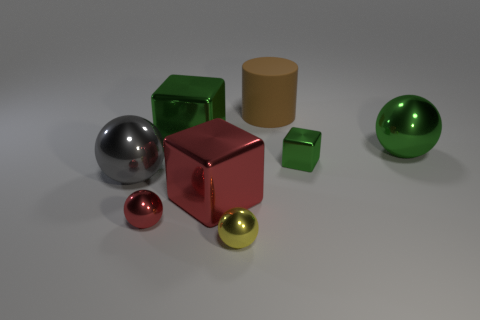Is there any other thing that is the same shape as the large matte thing?
Your answer should be very brief. No. What material is the sphere that is the same color as the small cube?
Provide a succinct answer. Metal. What is the shape of the metal thing that is to the right of the red cube and in front of the big red metal block?
Make the answer very short. Sphere. What is the material of the tiny green object that is right of the cube that is in front of the large gray sphere?
Provide a succinct answer. Metal. Are there more red metallic balls than large red matte balls?
Make the answer very short. Yes. Does the large matte object have the same color as the tiny cube?
Ensure brevity in your answer.  No. What material is the block that is the same size as the yellow shiny thing?
Your answer should be compact. Metal. Is the small green thing made of the same material as the large gray ball?
Offer a very short reply. Yes. What number of small green things have the same material as the yellow ball?
Give a very brief answer. 1. What number of objects are large spheres that are to the left of the yellow ball or things left of the green sphere?
Give a very brief answer. 7. 